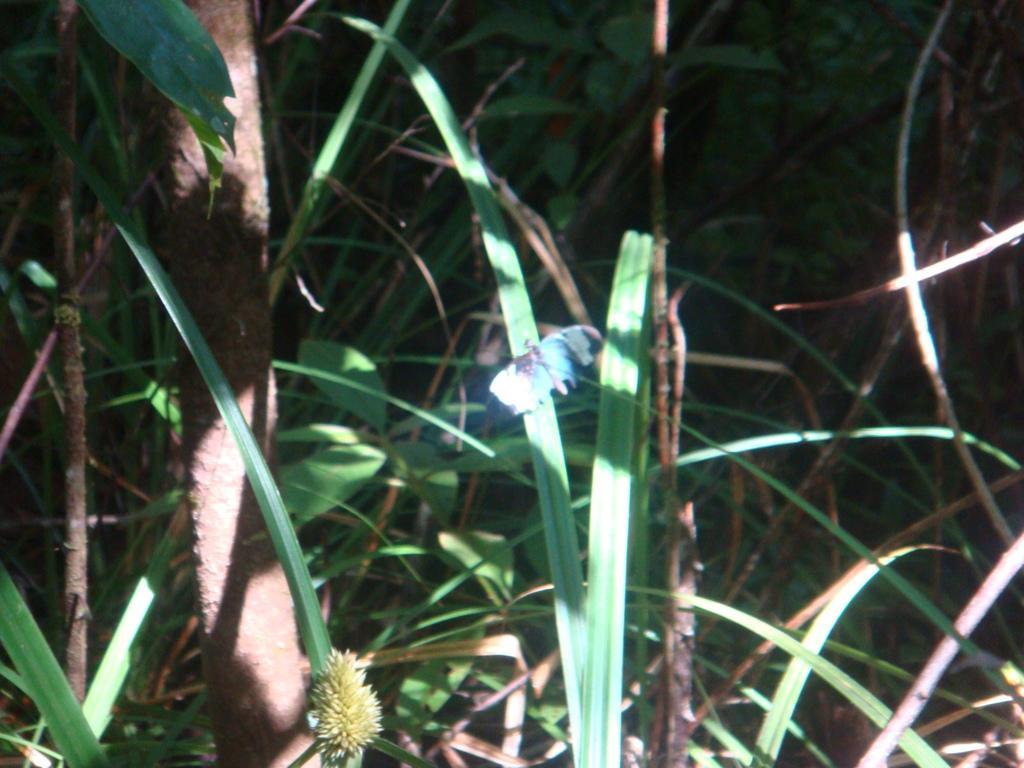In one or two sentences, can you explain what this image depicts? In this image we can see plants. 